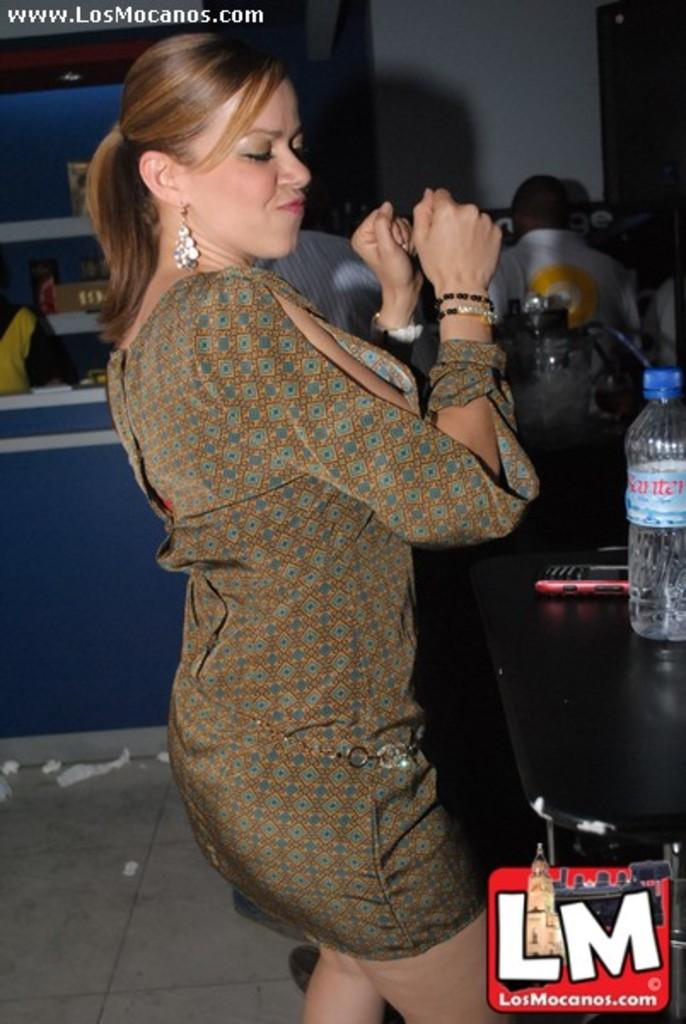What is the main subject of the image? There is a person in the image. What is the person wearing? The person is wearing a brown dress. What is the person doing in the image? The person is dancing. Where is the water bottle located in the image? The water bottle is on a shelf. What else is on the shelf in the image? The phone is also on the shelf. What type of advertisement can be seen in the background of the image? There is no advertisement present in the image. How does the fog affect the person's dancing in the image? There is no fog present in the image, so it does not affect the person's dancing. 